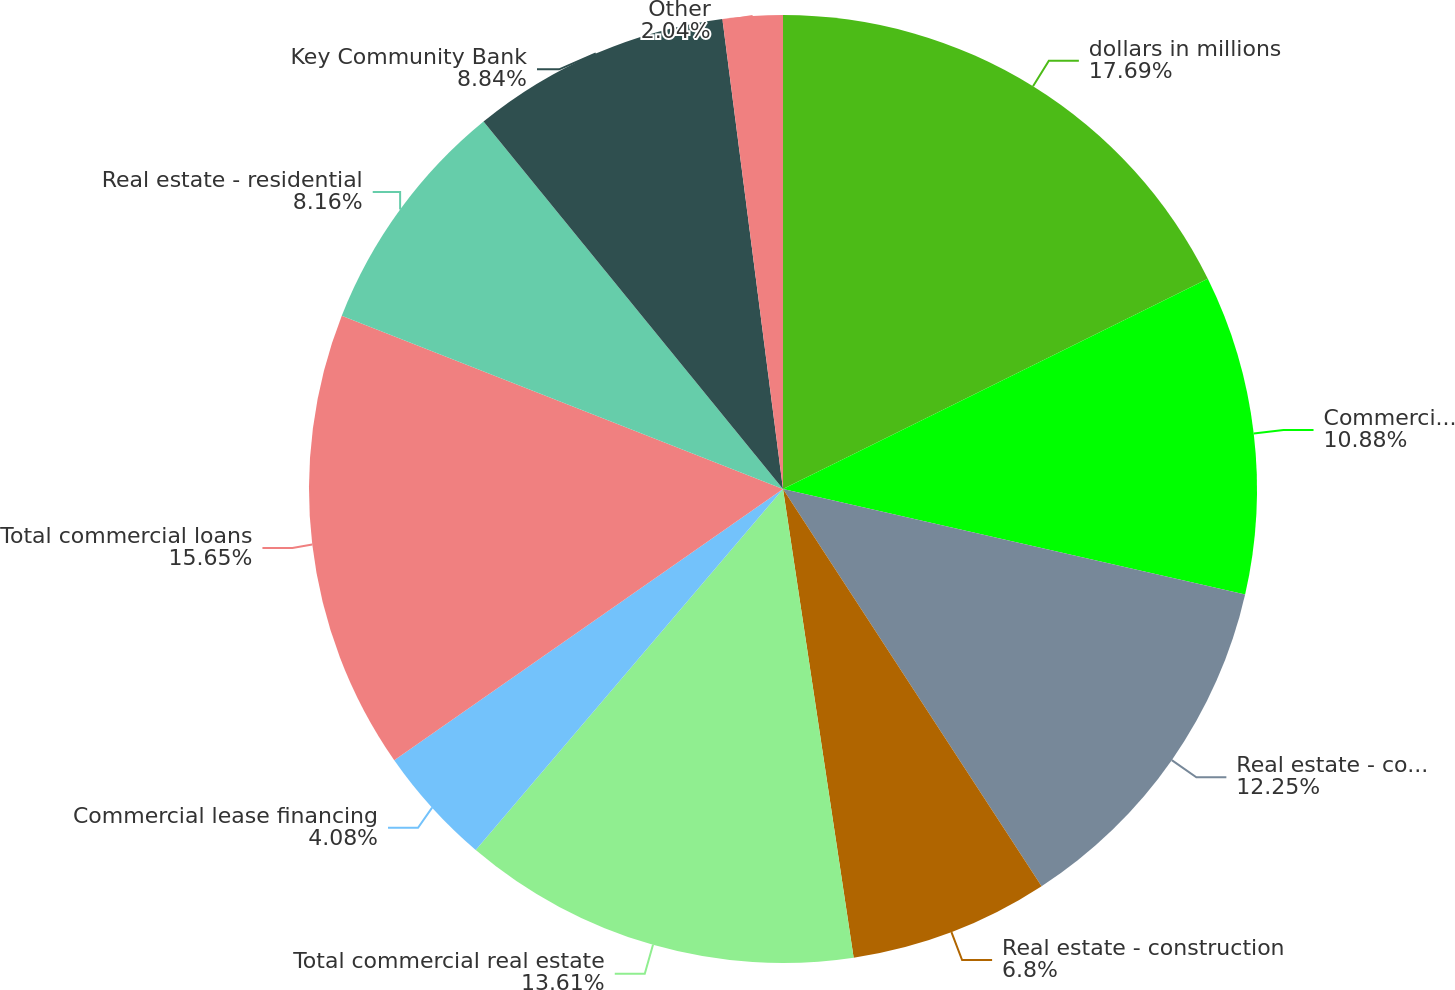<chart> <loc_0><loc_0><loc_500><loc_500><pie_chart><fcel>dollars in millions<fcel>Commercial financial and<fcel>Real estate - commercial<fcel>Real estate - construction<fcel>Total commercial real estate<fcel>Commercial lease financing<fcel>Total commercial loans<fcel>Real estate - residential<fcel>Key Community Bank<fcel>Other<nl><fcel>17.68%<fcel>10.88%<fcel>12.24%<fcel>6.8%<fcel>13.6%<fcel>4.08%<fcel>15.64%<fcel>8.16%<fcel>8.84%<fcel>2.04%<nl></chart> 